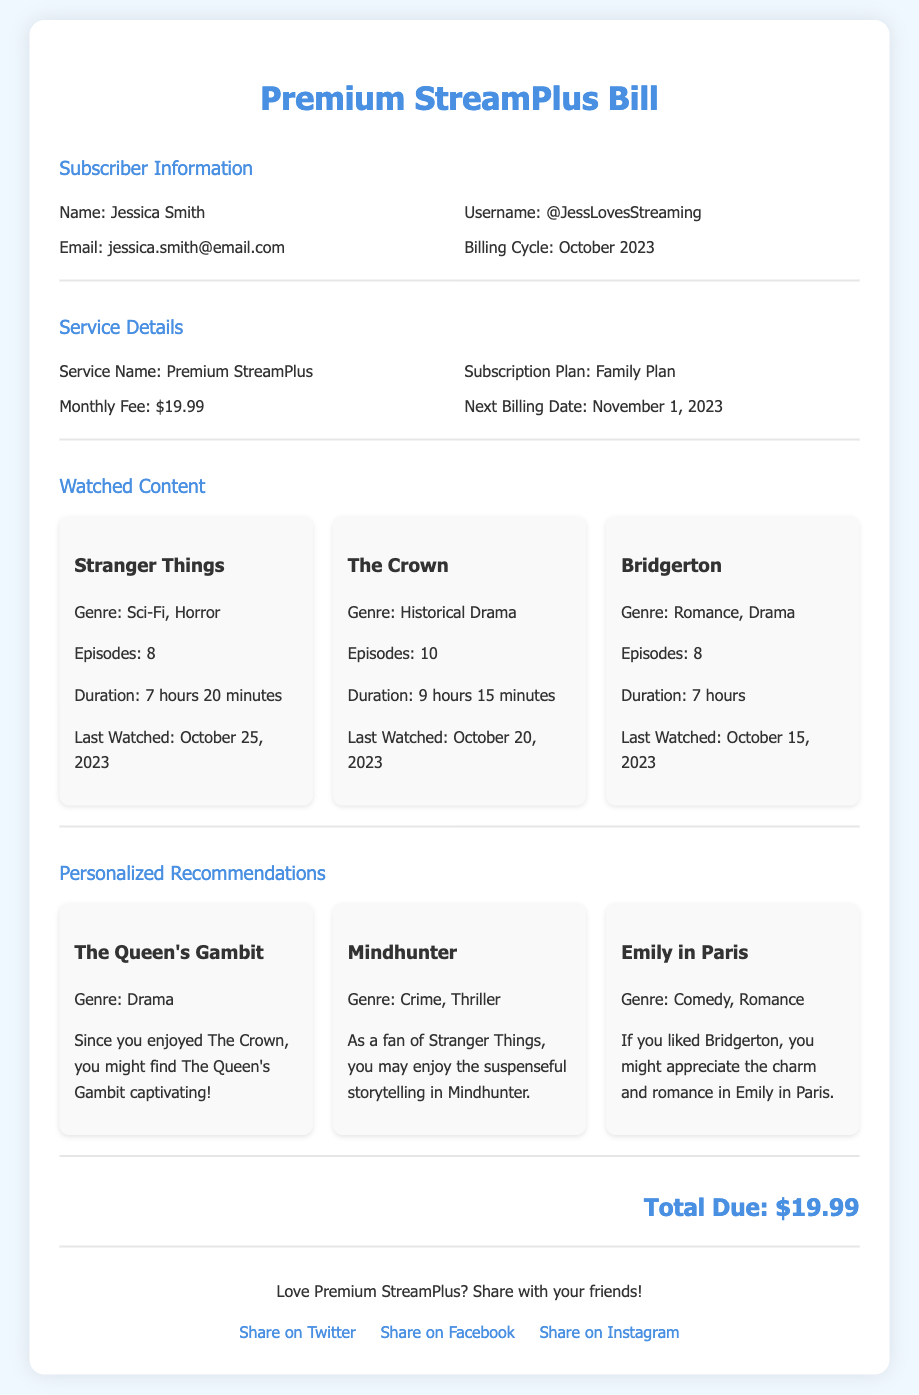What is the subscriber's name? The subscriber's name is displayed in the Subscriber Information section.
Answer: Jessica Smith What is the total due amount? The total amount due is listed in the last section of the document.
Answer: $19.99 When is the next billing date? The next billing date is mentioned under the Service Details section.
Answer: November 1, 2023 How many episodes were watched of The Crown? The number of episodes for The Crown is indicated in the Watched Content section.
Answer: 10 What genre is Mindhunter? The genre of Mindhunter is included in the Personalized Recommendations section.
Answer: Crime, Thriller Which streaming service does this bill belong to? The name of the streaming service is stated in the Service Details section.
Answer: Premium StreamPlus What is the subscription plan type? The subscription plan type is outlined in the Service Details section.
Answer: Family Plan Based on the bill, which show was last watched on October 25, 2023? The last watched show on that date is provided in the Watched Content section.
Answer: Stranger Things How many watched contents are listed? The total number of watched content is counted from the Watched Content section.
Answer: 3 